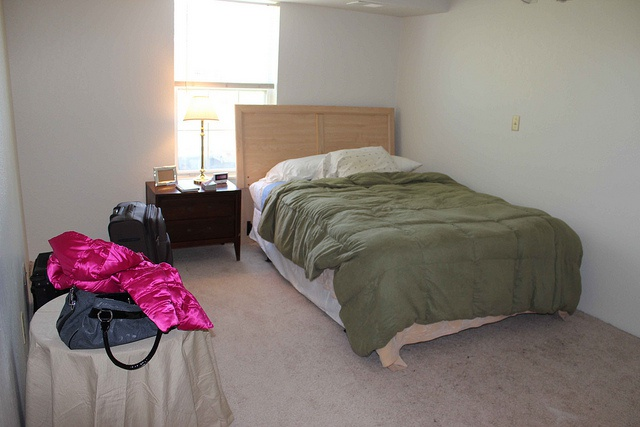Describe the objects in this image and their specific colors. I can see bed in gray, darkgreen, and darkgray tones, handbag in gray, black, and darkgray tones, suitcase in gray and black tones, suitcase in gray, black, darkgray, and maroon tones, and clock in gray, black, purple, and brown tones in this image. 